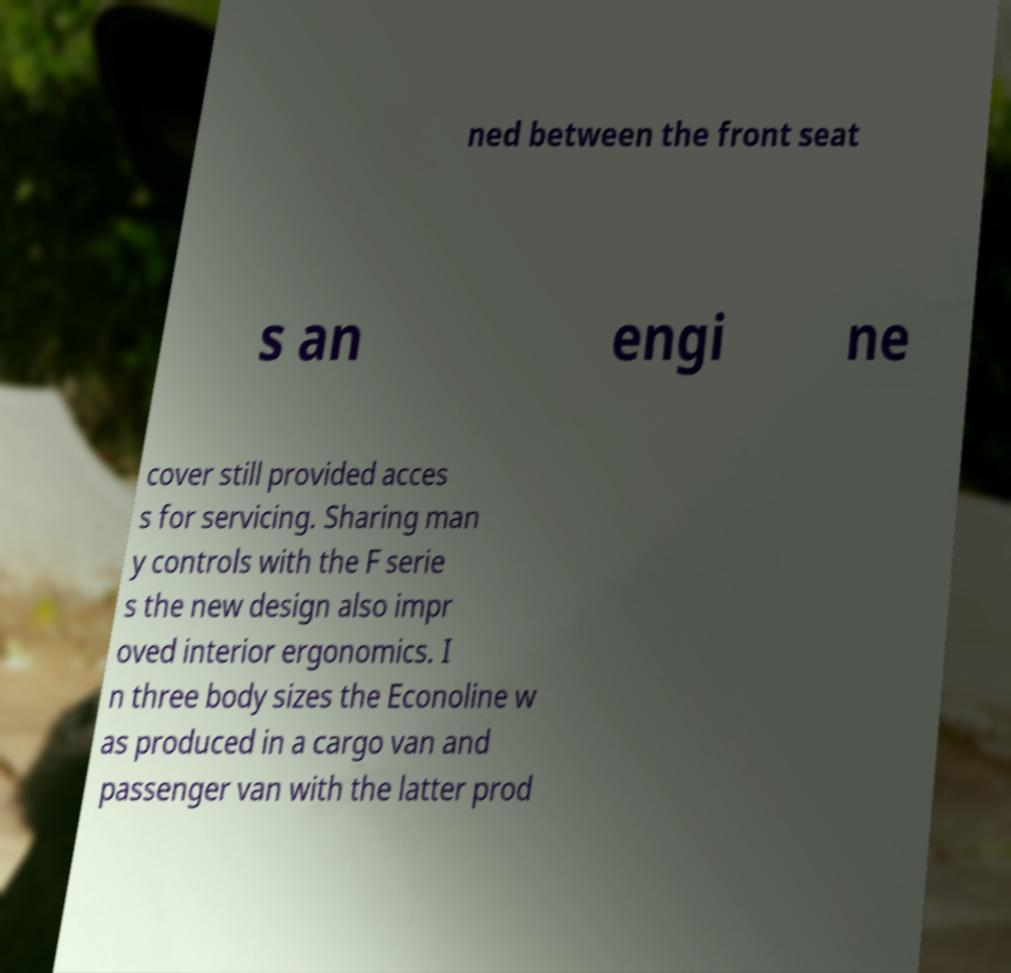Can you accurately transcribe the text from the provided image for me? ned between the front seat s an engi ne cover still provided acces s for servicing. Sharing man y controls with the F serie s the new design also impr oved interior ergonomics. I n three body sizes the Econoline w as produced in a cargo van and passenger van with the latter prod 